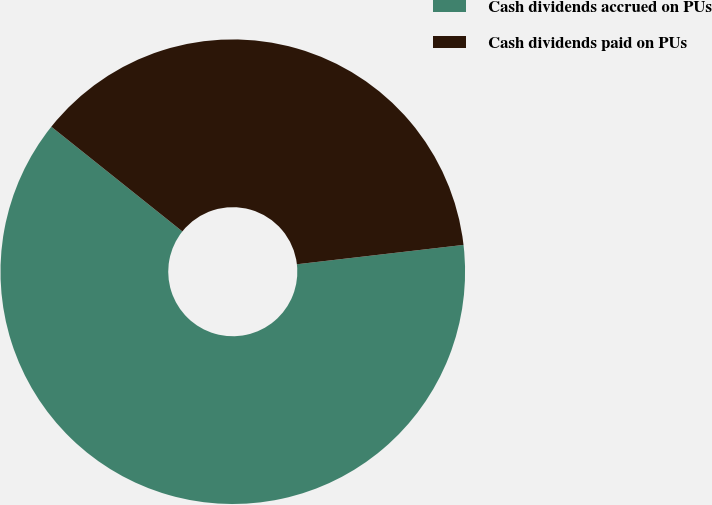<chart> <loc_0><loc_0><loc_500><loc_500><pie_chart><fcel>Cash dividends accrued on PUs<fcel>Cash dividends paid on PUs<nl><fcel>62.57%<fcel>37.43%<nl></chart> 